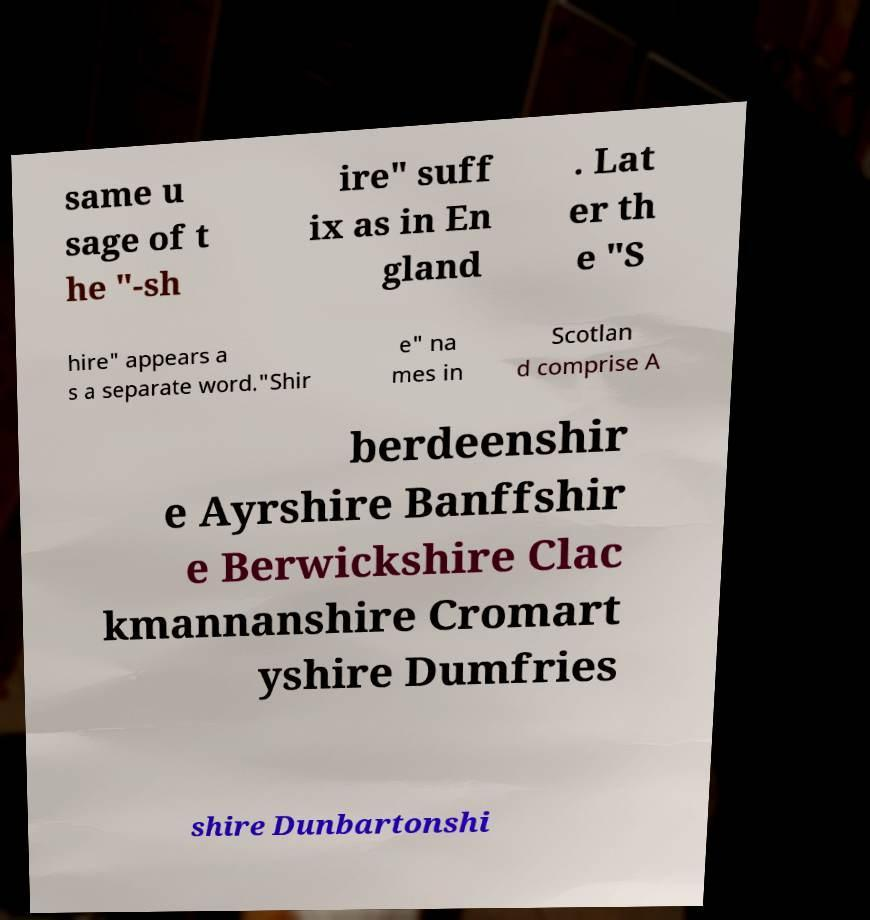I need the written content from this picture converted into text. Can you do that? same u sage of t he "-sh ire" suff ix as in En gland . Lat er th e "S hire" appears a s a separate word."Shir e" na mes in Scotlan d comprise A berdeenshir e Ayrshire Banffshir e Berwickshire Clac kmannanshire Cromart yshire Dumfries shire Dunbartonshi 